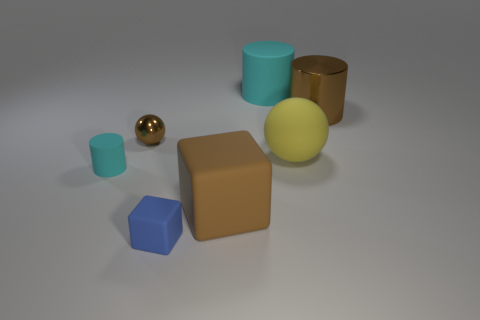Subtract all brown cubes. How many cyan cylinders are left? 2 Subtract all big cylinders. How many cylinders are left? 1 Add 1 blue shiny balls. How many objects exist? 8 Subtract all red cylinders. Subtract all yellow balls. How many cylinders are left? 3 Subtract all cylinders. How many objects are left? 4 Add 1 yellow things. How many yellow things are left? 2 Add 6 small blocks. How many small blocks exist? 7 Subtract 0 blue spheres. How many objects are left? 7 Subtract all matte balls. Subtract all yellow objects. How many objects are left? 5 